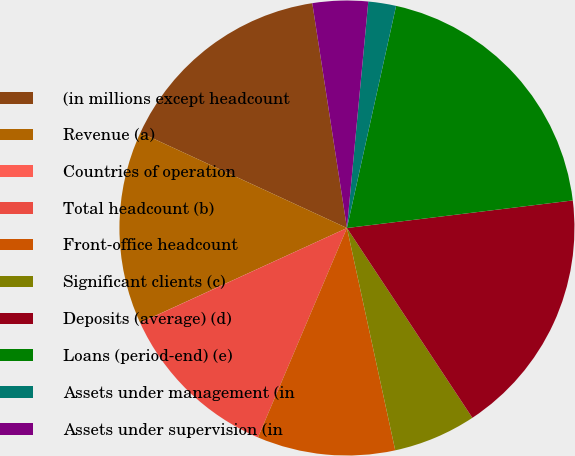Convert chart. <chart><loc_0><loc_0><loc_500><loc_500><pie_chart><fcel>(in millions except headcount<fcel>Revenue (a)<fcel>Countries of operation<fcel>Total headcount (b)<fcel>Front-office headcount<fcel>Significant clients (c)<fcel>Deposits (average) (d)<fcel>Loans (period-end) (e)<fcel>Assets under management (in<fcel>Assets under supervision (in<nl><fcel>15.68%<fcel>13.72%<fcel>0.01%<fcel>11.76%<fcel>9.8%<fcel>5.89%<fcel>17.64%<fcel>19.6%<fcel>1.97%<fcel>3.93%<nl></chart> 